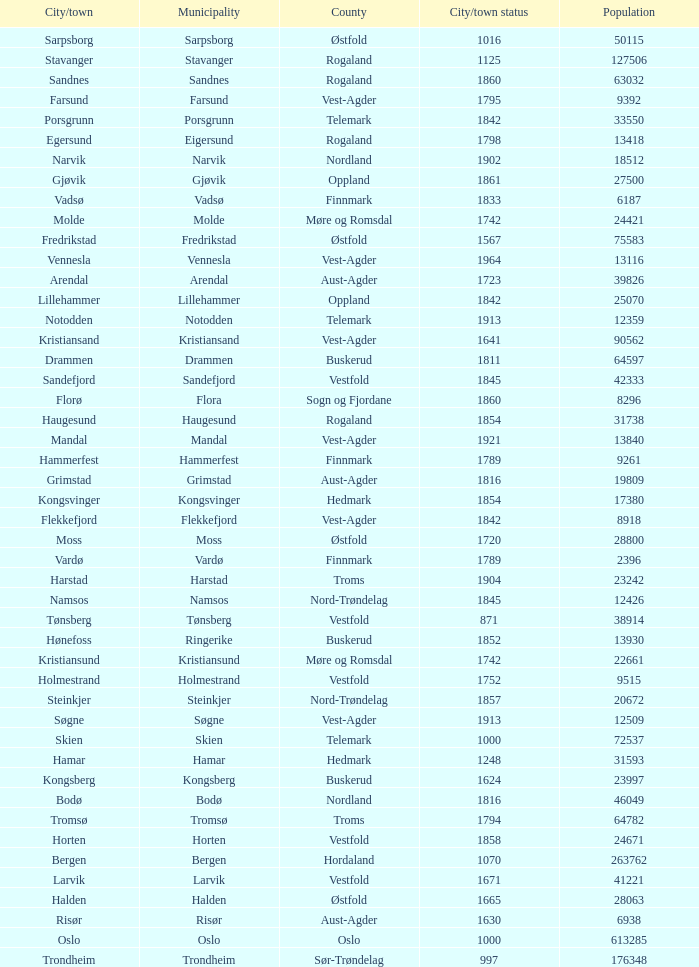What are the cities/towns located in the municipality of Moss? Moss. 